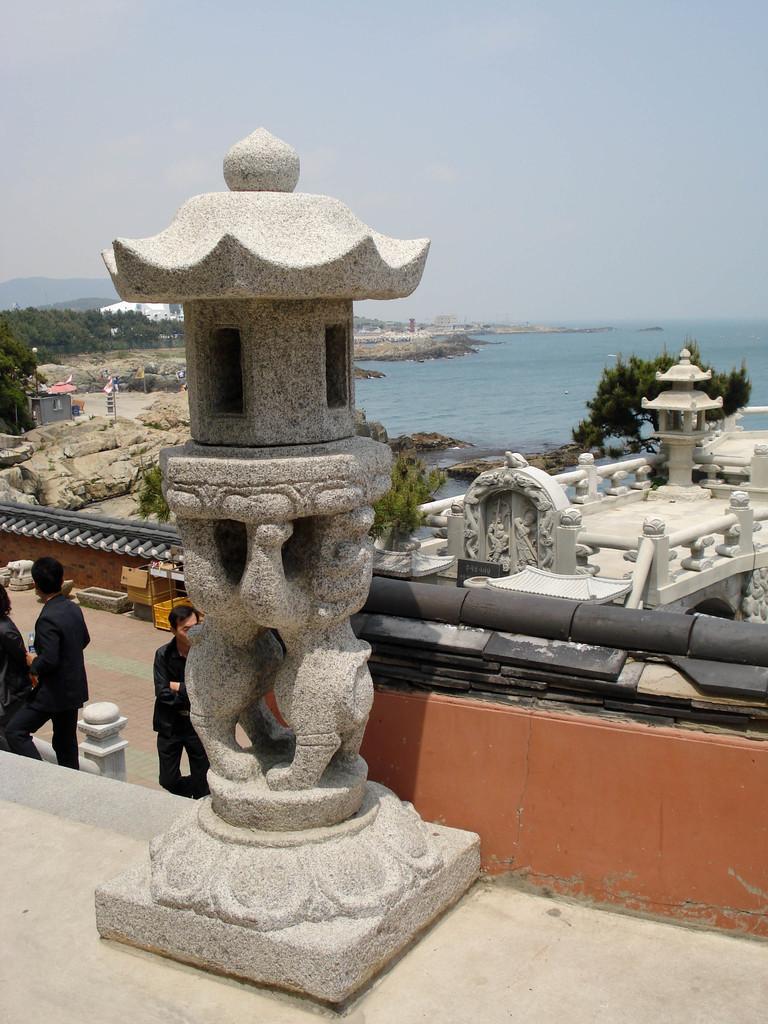Describe this image in one or two sentences. Here we can see a sculpture and there are three persons. Here we can see trees, rocks, and water. In the background there is sky. 